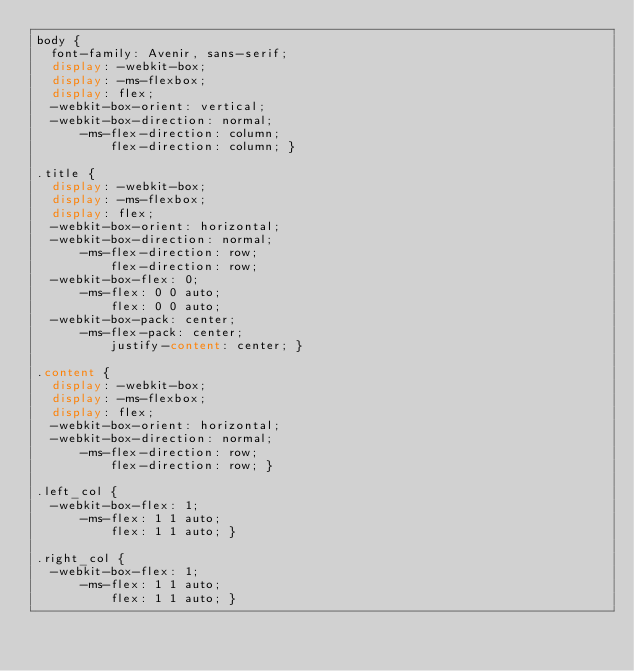Convert code to text. <code><loc_0><loc_0><loc_500><loc_500><_CSS_>body {
  font-family: Avenir, sans-serif;
  display: -webkit-box;
  display: -ms-flexbox;
  display: flex;
  -webkit-box-orient: vertical;
  -webkit-box-direction: normal;
      -ms-flex-direction: column;
          flex-direction: column; }

.title {
  display: -webkit-box;
  display: -ms-flexbox;
  display: flex;
  -webkit-box-orient: horizontal;
  -webkit-box-direction: normal;
      -ms-flex-direction: row;
          flex-direction: row;
  -webkit-box-flex: 0;
      -ms-flex: 0 0 auto;
          flex: 0 0 auto;
  -webkit-box-pack: center;
      -ms-flex-pack: center;
          justify-content: center; }

.content {
  display: -webkit-box;
  display: -ms-flexbox;
  display: flex;
  -webkit-box-orient: horizontal;
  -webkit-box-direction: normal;
      -ms-flex-direction: row;
          flex-direction: row; }

.left_col {
  -webkit-box-flex: 1;
      -ms-flex: 1 1 auto;
          flex: 1 1 auto; }

.right_col {
  -webkit-box-flex: 1;
      -ms-flex: 1 1 auto;
          flex: 1 1 auto; }
</code> 